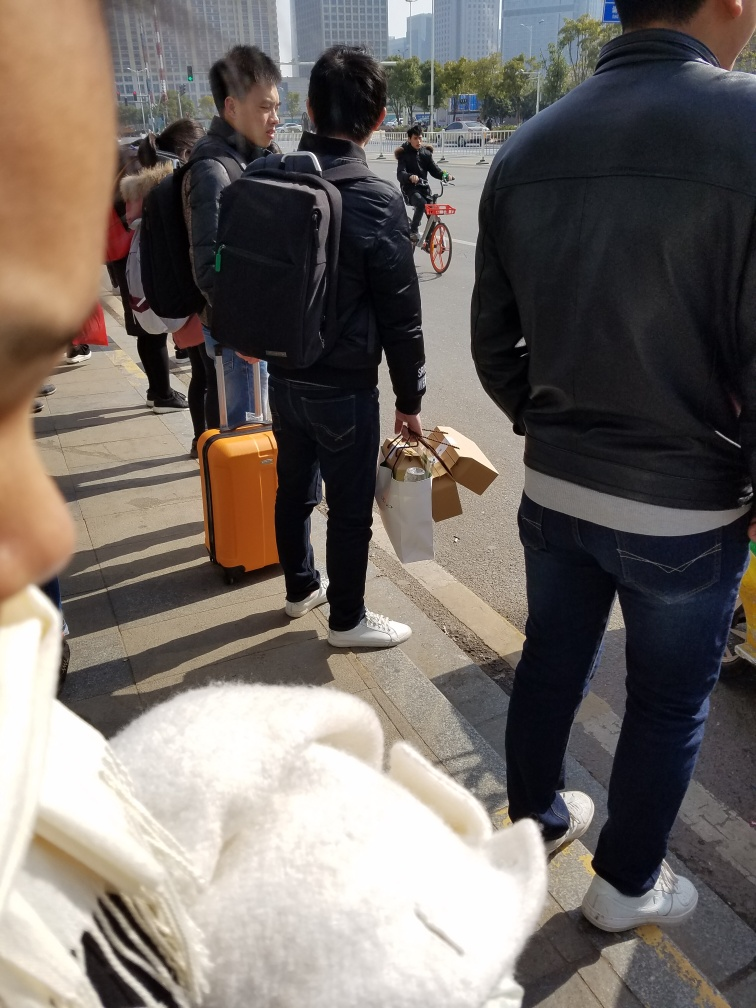What might the people in the photograph be waiting for? Based on the context clues, such as suitcases and bags in hand, it's possible that the individuals are waiting for transportation, like a taxi or bus, or they may be outside a public transportation hub like a train station or an airport. 